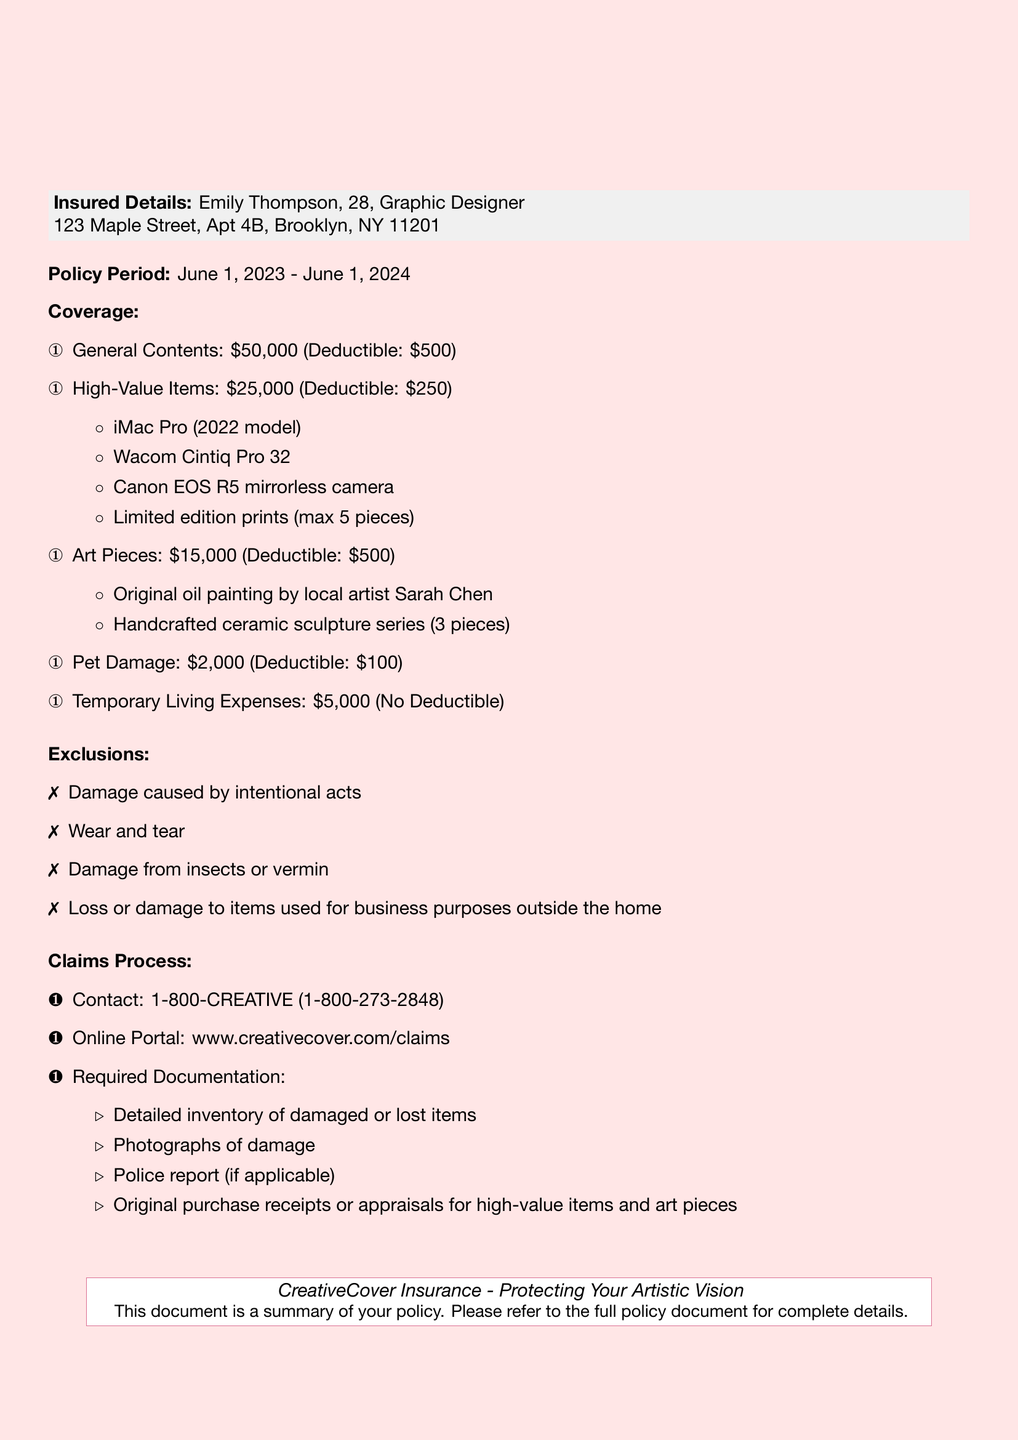What is the policy number? The policy number is explicitly stated in the document as GD-28-2023-0512.
Answer: GD-28-2023-0512 What is the coverage amount for general contents? The coverage is clearly listed in the document as $50,000.
Answer: $50,000 What is the deductible for high-value items? The deductible amount for high-value items is noted in the document as $250.
Answer: $250 How many original oil paintings are covered? The document specifies that one original oil painting by local artist Sarah Chen is covered.
Answer: One What is the coverage amount for art pieces? The document states that the coverage amount for art pieces is $15,000.
Answer: $15,000 Which items are excluded from the policy? The document lists several exclusions, including intentional acts and wear and tear.
Answer: Intentional acts, wear and tear What is the claims contact number? The contact number for claims is provided in the document as 1-800-CREATIVE.
Answer: 1-800-CREATIVE What is the maximum deductible for pet damage? The document indicates the deductible for pet damage is $100.
Answer: $100 What is included in the required documentation for claims? The document mentions that a detailed inventory, photographs, a police report, and purchase receipts are required.
Answer: Detailed inventory, photographs, police report, purchase receipts 